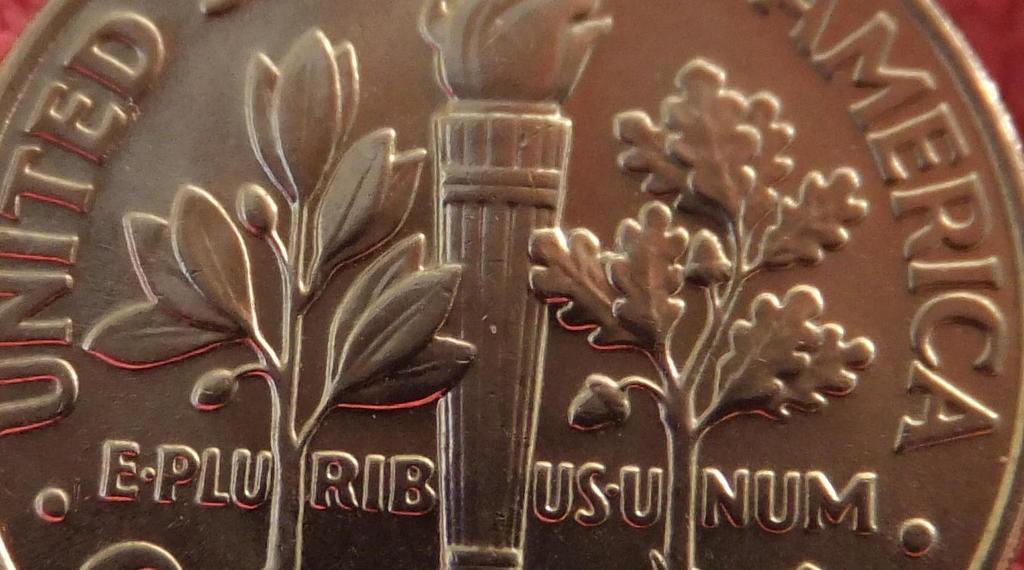Please provide a concise description of this image. Here we can see a coin and on it there are trees design and a text written on it. In the background there is an object. 